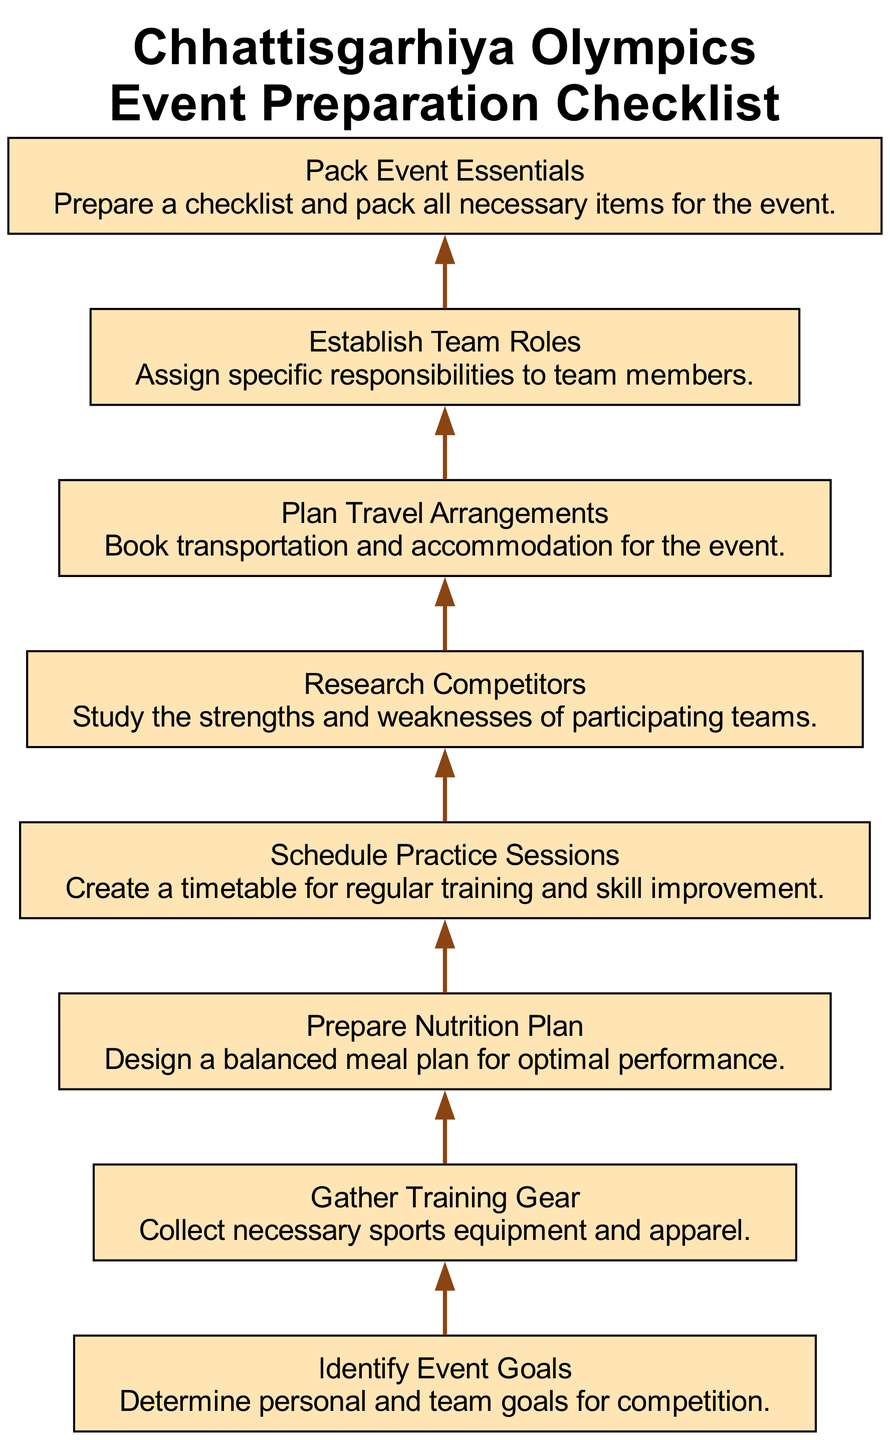What is the first step in the event preparation checklist? The first step in the checklist is "Identify Event Goals", which serves as the starting point for the preparation process. This is indicated by its position at the bottom of the flow chart.
Answer: Identify Event Goals How many elements are in the checklist? There are eight elements listed in the diagram that contribute to the overall event preparation for the Chhattisgarhiya Olympics. This can be counted directly from the nodes present in the flow chart.
Answer: Eight What follows the "Gather Training Gear" step? The step that follows "Gather Training Gear" in the flow of the diagram is "Prepare Nutrition Plan", as each step is connected sequentially from bottom to top in the chart.
Answer: Prepare Nutrition Plan Which step is directly above "Plan Travel Arrangements"? "Establish Team Roles" is the step directly above "Plan Travel Arrangements". This can be determined by moving one node up in the flow chart from "Plan Travel Arrangements".
Answer: Establish Team Roles What is the last step in the checklist? The last step in the preparation checklist is "Pack Event Essentials", as it is positioned at the top and signifies the culmination of the preparation process.
Answer: Pack Event Essentials How are the nodes connected in this diagram? The nodes are connected in a sequential manner with directed edges flowing from the first step "Identify Event Goals" at the bottom to the last step "Pack Event Essentials" at the top, illustrating a bottom to top flow.
Answer: Sequentially Which step focuses on optimizing performance through diet? The step focused on optimizing performance through diet is "Prepare Nutrition Plan", as stated in its description about designing a balanced meal plan.
Answer: Prepare Nutrition Plan What does researching competitors involve? Researching competitors involves studying the strengths and weaknesses of participating teams, as highlighted in the description for that step in the checklist.
Answer: Study strengths and weaknesses 